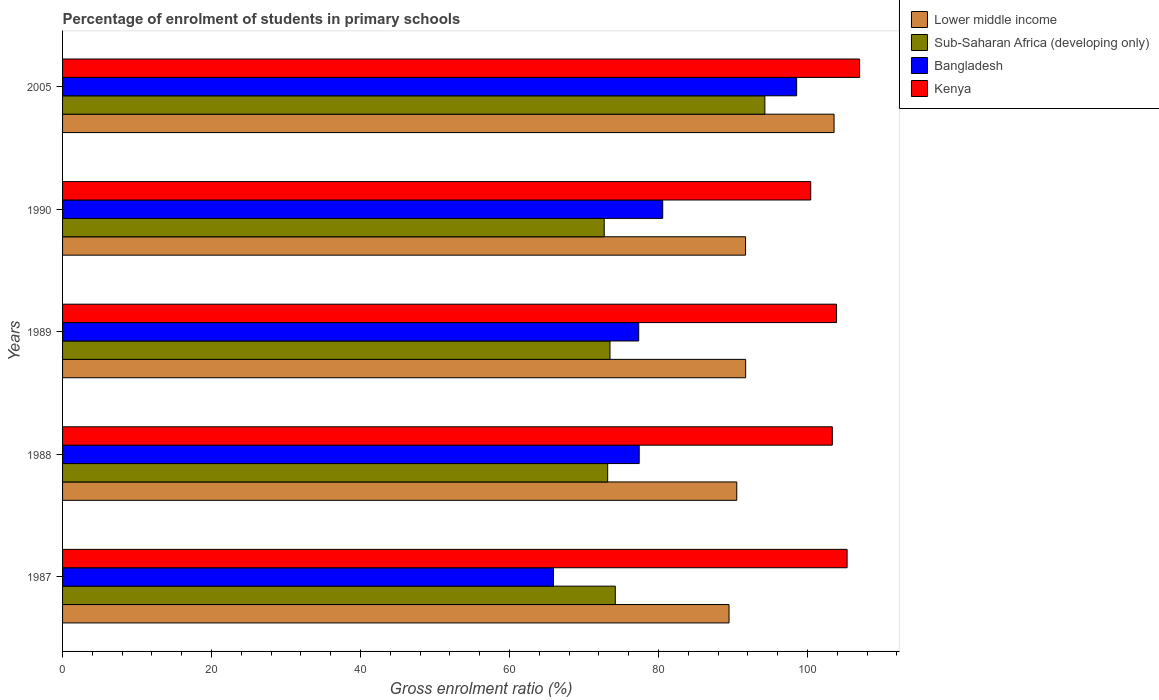How many groups of bars are there?
Your response must be concise. 5. Are the number of bars per tick equal to the number of legend labels?
Ensure brevity in your answer.  Yes. Are the number of bars on each tick of the Y-axis equal?
Your answer should be compact. Yes. How many bars are there on the 4th tick from the top?
Make the answer very short. 4. How many bars are there on the 4th tick from the bottom?
Your answer should be compact. 4. In how many cases, is the number of bars for a given year not equal to the number of legend labels?
Keep it short and to the point. 0. What is the percentage of students enrolled in primary schools in Lower middle income in 1988?
Offer a very short reply. 90.5. Across all years, what is the maximum percentage of students enrolled in primary schools in Bangladesh?
Ensure brevity in your answer.  98.54. Across all years, what is the minimum percentage of students enrolled in primary schools in Bangladesh?
Keep it short and to the point. 65.89. In which year was the percentage of students enrolled in primary schools in Kenya maximum?
Make the answer very short. 2005. In which year was the percentage of students enrolled in primary schools in Kenya minimum?
Your answer should be compact. 1990. What is the total percentage of students enrolled in primary schools in Lower middle income in the graph?
Ensure brevity in your answer.  466.91. What is the difference between the percentage of students enrolled in primary schools in Kenya in 1987 and that in 1988?
Your response must be concise. 1.99. What is the difference between the percentage of students enrolled in primary schools in Sub-Saharan Africa (developing only) in 1990 and the percentage of students enrolled in primary schools in Lower middle income in 2005?
Offer a very short reply. -30.85. What is the average percentage of students enrolled in primary schools in Sub-Saharan Africa (developing only) per year?
Offer a terse response. 77.57. In the year 1987, what is the difference between the percentage of students enrolled in primary schools in Sub-Saharan Africa (developing only) and percentage of students enrolled in primary schools in Bangladesh?
Your answer should be very brief. 8.3. What is the ratio of the percentage of students enrolled in primary schools in Lower middle income in 1988 to that in 2005?
Give a very brief answer. 0.87. Is the percentage of students enrolled in primary schools in Sub-Saharan Africa (developing only) in 1989 less than that in 2005?
Offer a very short reply. Yes. Is the difference between the percentage of students enrolled in primary schools in Sub-Saharan Africa (developing only) in 1987 and 1989 greater than the difference between the percentage of students enrolled in primary schools in Bangladesh in 1987 and 1989?
Ensure brevity in your answer.  Yes. What is the difference between the highest and the second highest percentage of students enrolled in primary schools in Lower middle income?
Provide a succinct answer. 11.87. What is the difference between the highest and the lowest percentage of students enrolled in primary schools in Sub-Saharan Africa (developing only)?
Ensure brevity in your answer.  21.57. Is the sum of the percentage of students enrolled in primary schools in Kenya in 1987 and 2005 greater than the maximum percentage of students enrolled in primary schools in Bangladesh across all years?
Your answer should be very brief. Yes. What does the 2nd bar from the top in 1989 represents?
Offer a very short reply. Bangladesh. Is it the case that in every year, the sum of the percentage of students enrolled in primary schools in Sub-Saharan Africa (developing only) and percentage of students enrolled in primary schools in Bangladesh is greater than the percentage of students enrolled in primary schools in Lower middle income?
Ensure brevity in your answer.  Yes. Are all the bars in the graph horizontal?
Offer a very short reply. Yes. Are the values on the major ticks of X-axis written in scientific E-notation?
Provide a succinct answer. No. Does the graph contain any zero values?
Your answer should be very brief. No. How many legend labels are there?
Offer a terse response. 4. What is the title of the graph?
Provide a short and direct response. Percentage of enrolment of students in primary schools. What is the label or title of the X-axis?
Provide a short and direct response. Gross enrolment ratio (%). What is the label or title of the Y-axis?
Your answer should be compact. Years. What is the Gross enrolment ratio (%) of Lower middle income in 1987?
Ensure brevity in your answer.  89.47. What is the Gross enrolment ratio (%) of Sub-Saharan Africa (developing only) in 1987?
Keep it short and to the point. 74.2. What is the Gross enrolment ratio (%) of Bangladesh in 1987?
Keep it short and to the point. 65.89. What is the Gross enrolment ratio (%) of Kenya in 1987?
Offer a terse response. 105.32. What is the Gross enrolment ratio (%) in Lower middle income in 1988?
Offer a terse response. 90.5. What is the Gross enrolment ratio (%) in Sub-Saharan Africa (developing only) in 1988?
Provide a succinct answer. 73.17. What is the Gross enrolment ratio (%) in Bangladesh in 1988?
Offer a terse response. 77.41. What is the Gross enrolment ratio (%) in Kenya in 1988?
Make the answer very short. 103.33. What is the Gross enrolment ratio (%) of Lower middle income in 1989?
Your answer should be compact. 91.7. What is the Gross enrolment ratio (%) in Sub-Saharan Africa (developing only) in 1989?
Provide a succinct answer. 73.49. What is the Gross enrolment ratio (%) in Bangladesh in 1989?
Provide a short and direct response. 77.34. What is the Gross enrolment ratio (%) in Kenya in 1989?
Make the answer very short. 103.9. What is the Gross enrolment ratio (%) of Lower middle income in 1990?
Keep it short and to the point. 91.68. What is the Gross enrolment ratio (%) in Sub-Saharan Africa (developing only) in 1990?
Make the answer very short. 72.71. What is the Gross enrolment ratio (%) in Bangladesh in 1990?
Ensure brevity in your answer.  80.56. What is the Gross enrolment ratio (%) in Kenya in 1990?
Your answer should be very brief. 100.43. What is the Gross enrolment ratio (%) in Lower middle income in 2005?
Your response must be concise. 103.56. What is the Gross enrolment ratio (%) in Sub-Saharan Africa (developing only) in 2005?
Provide a succinct answer. 94.28. What is the Gross enrolment ratio (%) in Bangladesh in 2005?
Your answer should be very brief. 98.54. What is the Gross enrolment ratio (%) of Kenya in 2005?
Provide a short and direct response. 106.99. Across all years, what is the maximum Gross enrolment ratio (%) in Lower middle income?
Ensure brevity in your answer.  103.56. Across all years, what is the maximum Gross enrolment ratio (%) in Sub-Saharan Africa (developing only)?
Your answer should be very brief. 94.28. Across all years, what is the maximum Gross enrolment ratio (%) of Bangladesh?
Provide a succinct answer. 98.54. Across all years, what is the maximum Gross enrolment ratio (%) of Kenya?
Offer a terse response. 106.99. Across all years, what is the minimum Gross enrolment ratio (%) in Lower middle income?
Provide a short and direct response. 89.47. Across all years, what is the minimum Gross enrolment ratio (%) of Sub-Saharan Africa (developing only)?
Make the answer very short. 72.71. Across all years, what is the minimum Gross enrolment ratio (%) in Bangladesh?
Give a very brief answer. 65.89. Across all years, what is the minimum Gross enrolment ratio (%) in Kenya?
Offer a very short reply. 100.43. What is the total Gross enrolment ratio (%) of Lower middle income in the graph?
Your response must be concise. 466.91. What is the total Gross enrolment ratio (%) in Sub-Saharan Africa (developing only) in the graph?
Your answer should be very brief. 387.84. What is the total Gross enrolment ratio (%) in Bangladesh in the graph?
Offer a very short reply. 399.75. What is the total Gross enrolment ratio (%) in Kenya in the graph?
Your answer should be very brief. 519.97. What is the difference between the Gross enrolment ratio (%) of Lower middle income in 1987 and that in 1988?
Offer a very short reply. -1.04. What is the difference between the Gross enrolment ratio (%) in Sub-Saharan Africa (developing only) in 1987 and that in 1988?
Offer a terse response. 1.02. What is the difference between the Gross enrolment ratio (%) of Bangladesh in 1987 and that in 1988?
Your answer should be very brief. -11.51. What is the difference between the Gross enrolment ratio (%) in Kenya in 1987 and that in 1988?
Your response must be concise. 1.99. What is the difference between the Gross enrolment ratio (%) of Lower middle income in 1987 and that in 1989?
Offer a terse response. -2.23. What is the difference between the Gross enrolment ratio (%) of Sub-Saharan Africa (developing only) in 1987 and that in 1989?
Offer a terse response. 0.71. What is the difference between the Gross enrolment ratio (%) in Bangladesh in 1987 and that in 1989?
Provide a succinct answer. -11.45. What is the difference between the Gross enrolment ratio (%) in Kenya in 1987 and that in 1989?
Provide a short and direct response. 1.42. What is the difference between the Gross enrolment ratio (%) in Lower middle income in 1987 and that in 1990?
Your answer should be compact. -2.22. What is the difference between the Gross enrolment ratio (%) of Sub-Saharan Africa (developing only) in 1987 and that in 1990?
Keep it short and to the point. 1.49. What is the difference between the Gross enrolment ratio (%) in Bangladesh in 1987 and that in 1990?
Your answer should be very brief. -14.67. What is the difference between the Gross enrolment ratio (%) in Kenya in 1987 and that in 1990?
Make the answer very short. 4.88. What is the difference between the Gross enrolment ratio (%) in Lower middle income in 1987 and that in 2005?
Your response must be concise. -14.1. What is the difference between the Gross enrolment ratio (%) of Sub-Saharan Africa (developing only) in 1987 and that in 2005?
Provide a short and direct response. -20.08. What is the difference between the Gross enrolment ratio (%) of Bangladesh in 1987 and that in 2005?
Keep it short and to the point. -32.65. What is the difference between the Gross enrolment ratio (%) in Kenya in 1987 and that in 2005?
Your answer should be very brief. -1.68. What is the difference between the Gross enrolment ratio (%) of Lower middle income in 1988 and that in 1989?
Make the answer very short. -1.19. What is the difference between the Gross enrolment ratio (%) in Sub-Saharan Africa (developing only) in 1988 and that in 1989?
Your answer should be compact. -0.31. What is the difference between the Gross enrolment ratio (%) of Bangladesh in 1988 and that in 1989?
Your answer should be very brief. 0.07. What is the difference between the Gross enrolment ratio (%) of Kenya in 1988 and that in 1989?
Your answer should be compact. -0.57. What is the difference between the Gross enrolment ratio (%) of Lower middle income in 1988 and that in 1990?
Give a very brief answer. -1.18. What is the difference between the Gross enrolment ratio (%) of Sub-Saharan Africa (developing only) in 1988 and that in 1990?
Offer a terse response. 0.46. What is the difference between the Gross enrolment ratio (%) of Bangladesh in 1988 and that in 1990?
Give a very brief answer. -3.16. What is the difference between the Gross enrolment ratio (%) of Kenya in 1988 and that in 1990?
Offer a very short reply. 2.9. What is the difference between the Gross enrolment ratio (%) of Lower middle income in 1988 and that in 2005?
Offer a very short reply. -13.06. What is the difference between the Gross enrolment ratio (%) in Sub-Saharan Africa (developing only) in 1988 and that in 2005?
Your response must be concise. -21.1. What is the difference between the Gross enrolment ratio (%) of Bangladesh in 1988 and that in 2005?
Ensure brevity in your answer.  -21.13. What is the difference between the Gross enrolment ratio (%) of Kenya in 1988 and that in 2005?
Keep it short and to the point. -3.66. What is the difference between the Gross enrolment ratio (%) of Lower middle income in 1989 and that in 1990?
Make the answer very short. 0.01. What is the difference between the Gross enrolment ratio (%) in Sub-Saharan Africa (developing only) in 1989 and that in 1990?
Your answer should be compact. 0.78. What is the difference between the Gross enrolment ratio (%) of Bangladesh in 1989 and that in 1990?
Offer a very short reply. -3.22. What is the difference between the Gross enrolment ratio (%) in Kenya in 1989 and that in 1990?
Offer a terse response. 3.46. What is the difference between the Gross enrolment ratio (%) in Lower middle income in 1989 and that in 2005?
Your response must be concise. -11.87. What is the difference between the Gross enrolment ratio (%) in Sub-Saharan Africa (developing only) in 1989 and that in 2005?
Your answer should be compact. -20.79. What is the difference between the Gross enrolment ratio (%) of Bangladesh in 1989 and that in 2005?
Make the answer very short. -21.2. What is the difference between the Gross enrolment ratio (%) in Kenya in 1989 and that in 2005?
Ensure brevity in your answer.  -3.09. What is the difference between the Gross enrolment ratio (%) of Lower middle income in 1990 and that in 2005?
Give a very brief answer. -11.88. What is the difference between the Gross enrolment ratio (%) of Sub-Saharan Africa (developing only) in 1990 and that in 2005?
Provide a short and direct response. -21.57. What is the difference between the Gross enrolment ratio (%) in Bangladesh in 1990 and that in 2005?
Offer a terse response. -17.98. What is the difference between the Gross enrolment ratio (%) of Kenya in 1990 and that in 2005?
Your response must be concise. -6.56. What is the difference between the Gross enrolment ratio (%) in Lower middle income in 1987 and the Gross enrolment ratio (%) in Sub-Saharan Africa (developing only) in 1988?
Keep it short and to the point. 16.29. What is the difference between the Gross enrolment ratio (%) in Lower middle income in 1987 and the Gross enrolment ratio (%) in Bangladesh in 1988?
Your answer should be very brief. 12.06. What is the difference between the Gross enrolment ratio (%) in Lower middle income in 1987 and the Gross enrolment ratio (%) in Kenya in 1988?
Offer a very short reply. -13.86. What is the difference between the Gross enrolment ratio (%) of Sub-Saharan Africa (developing only) in 1987 and the Gross enrolment ratio (%) of Bangladesh in 1988?
Keep it short and to the point. -3.21. What is the difference between the Gross enrolment ratio (%) in Sub-Saharan Africa (developing only) in 1987 and the Gross enrolment ratio (%) in Kenya in 1988?
Your answer should be very brief. -29.13. What is the difference between the Gross enrolment ratio (%) in Bangladesh in 1987 and the Gross enrolment ratio (%) in Kenya in 1988?
Ensure brevity in your answer.  -37.44. What is the difference between the Gross enrolment ratio (%) of Lower middle income in 1987 and the Gross enrolment ratio (%) of Sub-Saharan Africa (developing only) in 1989?
Make the answer very short. 15.98. What is the difference between the Gross enrolment ratio (%) of Lower middle income in 1987 and the Gross enrolment ratio (%) of Bangladesh in 1989?
Offer a very short reply. 12.12. What is the difference between the Gross enrolment ratio (%) in Lower middle income in 1987 and the Gross enrolment ratio (%) in Kenya in 1989?
Provide a succinct answer. -14.43. What is the difference between the Gross enrolment ratio (%) of Sub-Saharan Africa (developing only) in 1987 and the Gross enrolment ratio (%) of Bangladesh in 1989?
Your response must be concise. -3.14. What is the difference between the Gross enrolment ratio (%) in Sub-Saharan Africa (developing only) in 1987 and the Gross enrolment ratio (%) in Kenya in 1989?
Provide a short and direct response. -29.7. What is the difference between the Gross enrolment ratio (%) of Bangladesh in 1987 and the Gross enrolment ratio (%) of Kenya in 1989?
Make the answer very short. -38. What is the difference between the Gross enrolment ratio (%) of Lower middle income in 1987 and the Gross enrolment ratio (%) of Sub-Saharan Africa (developing only) in 1990?
Ensure brevity in your answer.  16.76. What is the difference between the Gross enrolment ratio (%) in Lower middle income in 1987 and the Gross enrolment ratio (%) in Bangladesh in 1990?
Your answer should be compact. 8.9. What is the difference between the Gross enrolment ratio (%) of Lower middle income in 1987 and the Gross enrolment ratio (%) of Kenya in 1990?
Keep it short and to the point. -10.97. What is the difference between the Gross enrolment ratio (%) of Sub-Saharan Africa (developing only) in 1987 and the Gross enrolment ratio (%) of Bangladesh in 1990?
Your answer should be compact. -6.37. What is the difference between the Gross enrolment ratio (%) in Sub-Saharan Africa (developing only) in 1987 and the Gross enrolment ratio (%) in Kenya in 1990?
Your answer should be very brief. -26.24. What is the difference between the Gross enrolment ratio (%) of Bangladesh in 1987 and the Gross enrolment ratio (%) of Kenya in 1990?
Make the answer very short. -34.54. What is the difference between the Gross enrolment ratio (%) of Lower middle income in 1987 and the Gross enrolment ratio (%) of Sub-Saharan Africa (developing only) in 2005?
Provide a short and direct response. -4.81. What is the difference between the Gross enrolment ratio (%) in Lower middle income in 1987 and the Gross enrolment ratio (%) in Bangladesh in 2005?
Provide a succinct answer. -9.08. What is the difference between the Gross enrolment ratio (%) of Lower middle income in 1987 and the Gross enrolment ratio (%) of Kenya in 2005?
Your answer should be compact. -17.53. What is the difference between the Gross enrolment ratio (%) of Sub-Saharan Africa (developing only) in 1987 and the Gross enrolment ratio (%) of Bangladesh in 2005?
Your response must be concise. -24.35. What is the difference between the Gross enrolment ratio (%) of Sub-Saharan Africa (developing only) in 1987 and the Gross enrolment ratio (%) of Kenya in 2005?
Provide a short and direct response. -32.79. What is the difference between the Gross enrolment ratio (%) in Bangladesh in 1987 and the Gross enrolment ratio (%) in Kenya in 2005?
Offer a very short reply. -41.1. What is the difference between the Gross enrolment ratio (%) of Lower middle income in 1988 and the Gross enrolment ratio (%) of Sub-Saharan Africa (developing only) in 1989?
Provide a short and direct response. 17.02. What is the difference between the Gross enrolment ratio (%) of Lower middle income in 1988 and the Gross enrolment ratio (%) of Bangladesh in 1989?
Offer a terse response. 13.16. What is the difference between the Gross enrolment ratio (%) of Lower middle income in 1988 and the Gross enrolment ratio (%) of Kenya in 1989?
Give a very brief answer. -13.39. What is the difference between the Gross enrolment ratio (%) of Sub-Saharan Africa (developing only) in 1988 and the Gross enrolment ratio (%) of Bangladesh in 1989?
Provide a succinct answer. -4.17. What is the difference between the Gross enrolment ratio (%) of Sub-Saharan Africa (developing only) in 1988 and the Gross enrolment ratio (%) of Kenya in 1989?
Keep it short and to the point. -30.72. What is the difference between the Gross enrolment ratio (%) of Bangladesh in 1988 and the Gross enrolment ratio (%) of Kenya in 1989?
Provide a succinct answer. -26.49. What is the difference between the Gross enrolment ratio (%) of Lower middle income in 1988 and the Gross enrolment ratio (%) of Sub-Saharan Africa (developing only) in 1990?
Ensure brevity in your answer.  17.79. What is the difference between the Gross enrolment ratio (%) in Lower middle income in 1988 and the Gross enrolment ratio (%) in Bangladesh in 1990?
Give a very brief answer. 9.94. What is the difference between the Gross enrolment ratio (%) of Lower middle income in 1988 and the Gross enrolment ratio (%) of Kenya in 1990?
Offer a terse response. -9.93. What is the difference between the Gross enrolment ratio (%) in Sub-Saharan Africa (developing only) in 1988 and the Gross enrolment ratio (%) in Bangladesh in 1990?
Keep it short and to the point. -7.39. What is the difference between the Gross enrolment ratio (%) of Sub-Saharan Africa (developing only) in 1988 and the Gross enrolment ratio (%) of Kenya in 1990?
Provide a succinct answer. -27.26. What is the difference between the Gross enrolment ratio (%) of Bangladesh in 1988 and the Gross enrolment ratio (%) of Kenya in 1990?
Offer a very short reply. -23.02. What is the difference between the Gross enrolment ratio (%) of Lower middle income in 1988 and the Gross enrolment ratio (%) of Sub-Saharan Africa (developing only) in 2005?
Provide a short and direct response. -3.77. What is the difference between the Gross enrolment ratio (%) in Lower middle income in 1988 and the Gross enrolment ratio (%) in Bangladesh in 2005?
Your answer should be very brief. -8.04. What is the difference between the Gross enrolment ratio (%) of Lower middle income in 1988 and the Gross enrolment ratio (%) of Kenya in 2005?
Your answer should be very brief. -16.49. What is the difference between the Gross enrolment ratio (%) in Sub-Saharan Africa (developing only) in 1988 and the Gross enrolment ratio (%) in Bangladesh in 2005?
Give a very brief answer. -25.37. What is the difference between the Gross enrolment ratio (%) of Sub-Saharan Africa (developing only) in 1988 and the Gross enrolment ratio (%) of Kenya in 2005?
Offer a terse response. -33.82. What is the difference between the Gross enrolment ratio (%) in Bangladesh in 1988 and the Gross enrolment ratio (%) in Kenya in 2005?
Your answer should be very brief. -29.58. What is the difference between the Gross enrolment ratio (%) in Lower middle income in 1989 and the Gross enrolment ratio (%) in Sub-Saharan Africa (developing only) in 1990?
Offer a terse response. 18.99. What is the difference between the Gross enrolment ratio (%) in Lower middle income in 1989 and the Gross enrolment ratio (%) in Bangladesh in 1990?
Offer a terse response. 11.13. What is the difference between the Gross enrolment ratio (%) of Lower middle income in 1989 and the Gross enrolment ratio (%) of Kenya in 1990?
Make the answer very short. -8.74. What is the difference between the Gross enrolment ratio (%) in Sub-Saharan Africa (developing only) in 1989 and the Gross enrolment ratio (%) in Bangladesh in 1990?
Make the answer very short. -7.08. What is the difference between the Gross enrolment ratio (%) in Sub-Saharan Africa (developing only) in 1989 and the Gross enrolment ratio (%) in Kenya in 1990?
Keep it short and to the point. -26.95. What is the difference between the Gross enrolment ratio (%) in Bangladesh in 1989 and the Gross enrolment ratio (%) in Kenya in 1990?
Make the answer very short. -23.09. What is the difference between the Gross enrolment ratio (%) in Lower middle income in 1989 and the Gross enrolment ratio (%) in Sub-Saharan Africa (developing only) in 2005?
Make the answer very short. -2.58. What is the difference between the Gross enrolment ratio (%) of Lower middle income in 1989 and the Gross enrolment ratio (%) of Bangladesh in 2005?
Your answer should be very brief. -6.85. What is the difference between the Gross enrolment ratio (%) in Lower middle income in 1989 and the Gross enrolment ratio (%) in Kenya in 2005?
Your answer should be compact. -15.29. What is the difference between the Gross enrolment ratio (%) of Sub-Saharan Africa (developing only) in 1989 and the Gross enrolment ratio (%) of Bangladesh in 2005?
Offer a very short reply. -25.06. What is the difference between the Gross enrolment ratio (%) of Sub-Saharan Africa (developing only) in 1989 and the Gross enrolment ratio (%) of Kenya in 2005?
Make the answer very short. -33.51. What is the difference between the Gross enrolment ratio (%) of Bangladesh in 1989 and the Gross enrolment ratio (%) of Kenya in 2005?
Give a very brief answer. -29.65. What is the difference between the Gross enrolment ratio (%) of Lower middle income in 1990 and the Gross enrolment ratio (%) of Sub-Saharan Africa (developing only) in 2005?
Provide a short and direct response. -2.59. What is the difference between the Gross enrolment ratio (%) of Lower middle income in 1990 and the Gross enrolment ratio (%) of Bangladesh in 2005?
Ensure brevity in your answer.  -6.86. What is the difference between the Gross enrolment ratio (%) in Lower middle income in 1990 and the Gross enrolment ratio (%) in Kenya in 2005?
Provide a succinct answer. -15.31. What is the difference between the Gross enrolment ratio (%) of Sub-Saharan Africa (developing only) in 1990 and the Gross enrolment ratio (%) of Bangladesh in 2005?
Provide a short and direct response. -25.83. What is the difference between the Gross enrolment ratio (%) of Sub-Saharan Africa (developing only) in 1990 and the Gross enrolment ratio (%) of Kenya in 2005?
Ensure brevity in your answer.  -34.28. What is the difference between the Gross enrolment ratio (%) in Bangladesh in 1990 and the Gross enrolment ratio (%) in Kenya in 2005?
Keep it short and to the point. -26.43. What is the average Gross enrolment ratio (%) in Lower middle income per year?
Provide a succinct answer. 93.38. What is the average Gross enrolment ratio (%) of Sub-Saharan Africa (developing only) per year?
Offer a terse response. 77.57. What is the average Gross enrolment ratio (%) of Bangladesh per year?
Provide a short and direct response. 79.95. What is the average Gross enrolment ratio (%) of Kenya per year?
Offer a terse response. 103.99. In the year 1987, what is the difference between the Gross enrolment ratio (%) in Lower middle income and Gross enrolment ratio (%) in Sub-Saharan Africa (developing only)?
Your answer should be compact. 15.27. In the year 1987, what is the difference between the Gross enrolment ratio (%) in Lower middle income and Gross enrolment ratio (%) in Bangladesh?
Make the answer very short. 23.57. In the year 1987, what is the difference between the Gross enrolment ratio (%) of Lower middle income and Gross enrolment ratio (%) of Kenya?
Make the answer very short. -15.85. In the year 1987, what is the difference between the Gross enrolment ratio (%) of Sub-Saharan Africa (developing only) and Gross enrolment ratio (%) of Bangladesh?
Provide a short and direct response. 8.3. In the year 1987, what is the difference between the Gross enrolment ratio (%) of Sub-Saharan Africa (developing only) and Gross enrolment ratio (%) of Kenya?
Your response must be concise. -31.12. In the year 1987, what is the difference between the Gross enrolment ratio (%) of Bangladesh and Gross enrolment ratio (%) of Kenya?
Make the answer very short. -39.42. In the year 1988, what is the difference between the Gross enrolment ratio (%) in Lower middle income and Gross enrolment ratio (%) in Sub-Saharan Africa (developing only)?
Ensure brevity in your answer.  17.33. In the year 1988, what is the difference between the Gross enrolment ratio (%) in Lower middle income and Gross enrolment ratio (%) in Bangladesh?
Ensure brevity in your answer.  13.1. In the year 1988, what is the difference between the Gross enrolment ratio (%) in Lower middle income and Gross enrolment ratio (%) in Kenya?
Your answer should be compact. -12.83. In the year 1988, what is the difference between the Gross enrolment ratio (%) of Sub-Saharan Africa (developing only) and Gross enrolment ratio (%) of Bangladesh?
Make the answer very short. -4.24. In the year 1988, what is the difference between the Gross enrolment ratio (%) of Sub-Saharan Africa (developing only) and Gross enrolment ratio (%) of Kenya?
Your answer should be very brief. -30.16. In the year 1988, what is the difference between the Gross enrolment ratio (%) in Bangladesh and Gross enrolment ratio (%) in Kenya?
Give a very brief answer. -25.92. In the year 1989, what is the difference between the Gross enrolment ratio (%) of Lower middle income and Gross enrolment ratio (%) of Sub-Saharan Africa (developing only)?
Keep it short and to the point. 18.21. In the year 1989, what is the difference between the Gross enrolment ratio (%) of Lower middle income and Gross enrolment ratio (%) of Bangladesh?
Keep it short and to the point. 14.36. In the year 1989, what is the difference between the Gross enrolment ratio (%) of Lower middle income and Gross enrolment ratio (%) of Kenya?
Offer a very short reply. -12.2. In the year 1989, what is the difference between the Gross enrolment ratio (%) in Sub-Saharan Africa (developing only) and Gross enrolment ratio (%) in Bangladesh?
Offer a very short reply. -3.85. In the year 1989, what is the difference between the Gross enrolment ratio (%) of Sub-Saharan Africa (developing only) and Gross enrolment ratio (%) of Kenya?
Make the answer very short. -30.41. In the year 1989, what is the difference between the Gross enrolment ratio (%) in Bangladesh and Gross enrolment ratio (%) in Kenya?
Your response must be concise. -26.56. In the year 1990, what is the difference between the Gross enrolment ratio (%) in Lower middle income and Gross enrolment ratio (%) in Sub-Saharan Africa (developing only)?
Offer a very short reply. 18.97. In the year 1990, what is the difference between the Gross enrolment ratio (%) of Lower middle income and Gross enrolment ratio (%) of Bangladesh?
Your answer should be compact. 11.12. In the year 1990, what is the difference between the Gross enrolment ratio (%) in Lower middle income and Gross enrolment ratio (%) in Kenya?
Your response must be concise. -8.75. In the year 1990, what is the difference between the Gross enrolment ratio (%) in Sub-Saharan Africa (developing only) and Gross enrolment ratio (%) in Bangladesh?
Your answer should be compact. -7.85. In the year 1990, what is the difference between the Gross enrolment ratio (%) of Sub-Saharan Africa (developing only) and Gross enrolment ratio (%) of Kenya?
Provide a succinct answer. -27.72. In the year 1990, what is the difference between the Gross enrolment ratio (%) in Bangladesh and Gross enrolment ratio (%) in Kenya?
Your response must be concise. -19.87. In the year 2005, what is the difference between the Gross enrolment ratio (%) of Lower middle income and Gross enrolment ratio (%) of Sub-Saharan Africa (developing only)?
Offer a very short reply. 9.29. In the year 2005, what is the difference between the Gross enrolment ratio (%) of Lower middle income and Gross enrolment ratio (%) of Bangladesh?
Your answer should be compact. 5.02. In the year 2005, what is the difference between the Gross enrolment ratio (%) of Lower middle income and Gross enrolment ratio (%) of Kenya?
Offer a very short reply. -3.43. In the year 2005, what is the difference between the Gross enrolment ratio (%) in Sub-Saharan Africa (developing only) and Gross enrolment ratio (%) in Bangladesh?
Offer a very short reply. -4.27. In the year 2005, what is the difference between the Gross enrolment ratio (%) in Sub-Saharan Africa (developing only) and Gross enrolment ratio (%) in Kenya?
Your response must be concise. -12.71. In the year 2005, what is the difference between the Gross enrolment ratio (%) of Bangladesh and Gross enrolment ratio (%) of Kenya?
Make the answer very short. -8.45. What is the ratio of the Gross enrolment ratio (%) in Bangladesh in 1987 to that in 1988?
Your response must be concise. 0.85. What is the ratio of the Gross enrolment ratio (%) of Kenya in 1987 to that in 1988?
Your answer should be very brief. 1.02. What is the ratio of the Gross enrolment ratio (%) of Lower middle income in 1987 to that in 1989?
Ensure brevity in your answer.  0.98. What is the ratio of the Gross enrolment ratio (%) of Sub-Saharan Africa (developing only) in 1987 to that in 1989?
Offer a terse response. 1.01. What is the ratio of the Gross enrolment ratio (%) in Bangladesh in 1987 to that in 1989?
Your answer should be compact. 0.85. What is the ratio of the Gross enrolment ratio (%) in Kenya in 1987 to that in 1989?
Offer a terse response. 1.01. What is the ratio of the Gross enrolment ratio (%) of Lower middle income in 1987 to that in 1990?
Your answer should be compact. 0.98. What is the ratio of the Gross enrolment ratio (%) of Sub-Saharan Africa (developing only) in 1987 to that in 1990?
Your answer should be very brief. 1.02. What is the ratio of the Gross enrolment ratio (%) of Bangladesh in 1987 to that in 1990?
Ensure brevity in your answer.  0.82. What is the ratio of the Gross enrolment ratio (%) of Kenya in 1987 to that in 1990?
Keep it short and to the point. 1.05. What is the ratio of the Gross enrolment ratio (%) in Lower middle income in 1987 to that in 2005?
Your response must be concise. 0.86. What is the ratio of the Gross enrolment ratio (%) in Sub-Saharan Africa (developing only) in 1987 to that in 2005?
Provide a short and direct response. 0.79. What is the ratio of the Gross enrolment ratio (%) of Bangladesh in 1987 to that in 2005?
Provide a short and direct response. 0.67. What is the ratio of the Gross enrolment ratio (%) in Kenya in 1987 to that in 2005?
Your answer should be very brief. 0.98. What is the ratio of the Gross enrolment ratio (%) in Kenya in 1988 to that in 1989?
Make the answer very short. 0.99. What is the ratio of the Gross enrolment ratio (%) in Lower middle income in 1988 to that in 1990?
Make the answer very short. 0.99. What is the ratio of the Gross enrolment ratio (%) in Sub-Saharan Africa (developing only) in 1988 to that in 1990?
Offer a very short reply. 1.01. What is the ratio of the Gross enrolment ratio (%) in Bangladesh in 1988 to that in 1990?
Give a very brief answer. 0.96. What is the ratio of the Gross enrolment ratio (%) in Kenya in 1988 to that in 1990?
Ensure brevity in your answer.  1.03. What is the ratio of the Gross enrolment ratio (%) in Lower middle income in 1988 to that in 2005?
Your answer should be very brief. 0.87. What is the ratio of the Gross enrolment ratio (%) in Sub-Saharan Africa (developing only) in 1988 to that in 2005?
Your answer should be compact. 0.78. What is the ratio of the Gross enrolment ratio (%) of Bangladesh in 1988 to that in 2005?
Give a very brief answer. 0.79. What is the ratio of the Gross enrolment ratio (%) of Kenya in 1988 to that in 2005?
Provide a short and direct response. 0.97. What is the ratio of the Gross enrolment ratio (%) in Lower middle income in 1989 to that in 1990?
Provide a short and direct response. 1. What is the ratio of the Gross enrolment ratio (%) of Sub-Saharan Africa (developing only) in 1989 to that in 1990?
Make the answer very short. 1.01. What is the ratio of the Gross enrolment ratio (%) of Bangladesh in 1989 to that in 1990?
Your response must be concise. 0.96. What is the ratio of the Gross enrolment ratio (%) in Kenya in 1989 to that in 1990?
Your answer should be compact. 1.03. What is the ratio of the Gross enrolment ratio (%) in Lower middle income in 1989 to that in 2005?
Your answer should be compact. 0.89. What is the ratio of the Gross enrolment ratio (%) in Sub-Saharan Africa (developing only) in 1989 to that in 2005?
Provide a short and direct response. 0.78. What is the ratio of the Gross enrolment ratio (%) in Bangladesh in 1989 to that in 2005?
Give a very brief answer. 0.78. What is the ratio of the Gross enrolment ratio (%) of Kenya in 1989 to that in 2005?
Your response must be concise. 0.97. What is the ratio of the Gross enrolment ratio (%) of Lower middle income in 1990 to that in 2005?
Give a very brief answer. 0.89. What is the ratio of the Gross enrolment ratio (%) of Sub-Saharan Africa (developing only) in 1990 to that in 2005?
Your answer should be compact. 0.77. What is the ratio of the Gross enrolment ratio (%) of Bangladesh in 1990 to that in 2005?
Make the answer very short. 0.82. What is the ratio of the Gross enrolment ratio (%) of Kenya in 1990 to that in 2005?
Offer a terse response. 0.94. What is the difference between the highest and the second highest Gross enrolment ratio (%) of Lower middle income?
Make the answer very short. 11.87. What is the difference between the highest and the second highest Gross enrolment ratio (%) of Sub-Saharan Africa (developing only)?
Your answer should be very brief. 20.08. What is the difference between the highest and the second highest Gross enrolment ratio (%) of Bangladesh?
Give a very brief answer. 17.98. What is the difference between the highest and the second highest Gross enrolment ratio (%) of Kenya?
Your answer should be very brief. 1.68. What is the difference between the highest and the lowest Gross enrolment ratio (%) in Lower middle income?
Your response must be concise. 14.1. What is the difference between the highest and the lowest Gross enrolment ratio (%) in Sub-Saharan Africa (developing only)?
Your answer should be very brief. 21.57. What is the difference between the highest and the lowest Gross enrolment ratio (%) in Bangladesh?
Offer a terse response. 32.65. What is the difference between the highest and the lowest Gross enrolment ratio (%) in Kenya?
Your answer should be very brief. 6.56. 